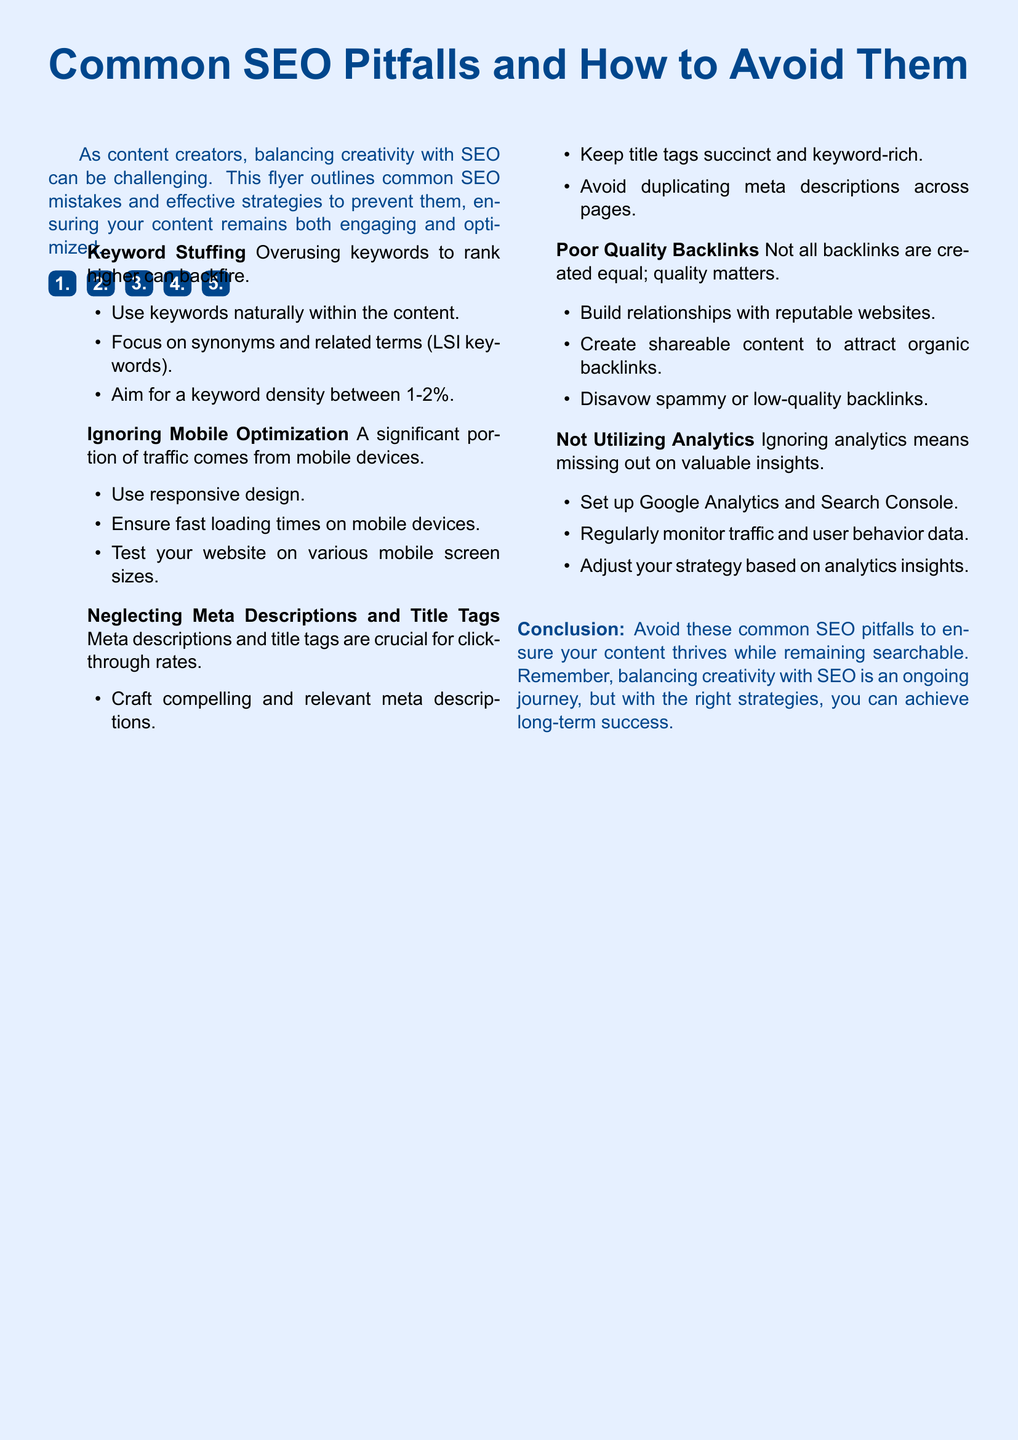What is the title of the flyer? The title is prominently displayed at the top of the flyer.
Answer: Common SEO Pitfalls and How to Avoid Them How many common SEO pitfalls are listed? The flyer outlines a specific number of pitfalls.
Answer: 5 What is a recommended keyword density? This information is provided as a guideline for SEO practices.
Answer: 1-2% What is the significance of meta descriptions? The flyer highlights their role in user engagement and SEO.
Answer: Click-through rates What is one way to improve mobile optimization? The flyer suggests specific strategies to enhance mobile experience.
Answer: Use responsive design What should you avoid doing with backlinks? This refers to the quality of backlinks in relation to SEO strategy.
Answer: Poor quality backlinks How often should you monitor analytics? The flyer implies a regular practice for effective SEO.
Answer: Regularly What does the conclusion emphasize? The flyer wraps up with a key takeaway for content creators.
Answer: Avoid common SEO pitfalls 